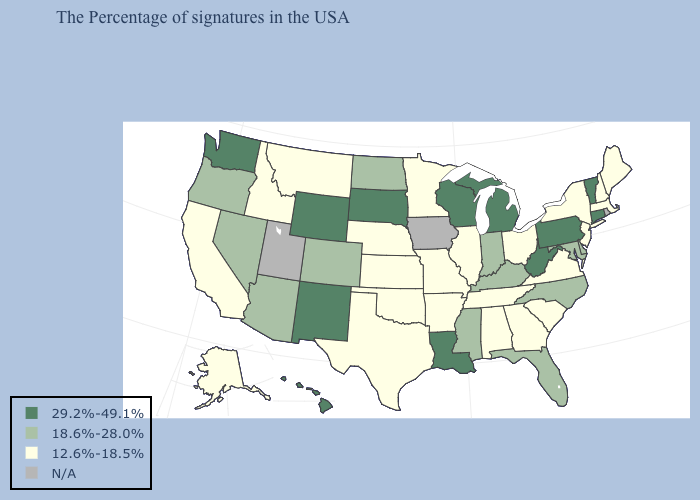What is the lowest value in the USA?
Write a very short answer. 12.6%-18.5%. What is the value of Nebraska?
Short answer required. 12.6%-18.5%. What is the value of Arizona?
Write a very short answer. 18.6%-28.0%. Name the states that have a value in the range 12.6%-18.5%?
Be succinct. Maine, Massachusetts, New Hampshire, New York, New Jersey, Virginia, South Carolina, Ohio, Georgia, Alabama, Tennessee, Illinois, Missouri, Arkansas, Minnesota, Kansas, Nebraska, Oklahoma, Texas, Montana, Idaho, California, Alaska. Name the states that have a value in the range 29.2%-49.1%?
Quick response, please. Vermont, Connecticut, Pennsylvania, West Virginia, Michigan, Wisconsin, Louisiana, South Dakota, Wyoming, New Mexico, Washington, Hawaii. Does the map have missing data?
Be succinct. Yes. Does the map have missing data?
Short answer required. Yes. What is the value of Montana?
Concise answer only. 12.6%-18.5%. Does Florida have the lowest value in the USA?
Short answer required. No. Does Idaho have the lowest value in the West?
Short answer required. Yes. Which states have the highest value in the USA?
Give a very brief answer. Vermont, Connecticut, Pennsylvania, West Virginia, Michigan, Wisconsin, Louisiana, South Dakota, Wyoming, New Mexico, Washington, Hawaii. What is the highest value in states that border Virginia?
Concise answer only. 29.2%-49.1%. What is the lowest value in the USA?
Keep it brief. 12.6%-18.5%. What is the highest value in states that border Oregon?
Quick response, please. 29.2%-49.1%. 